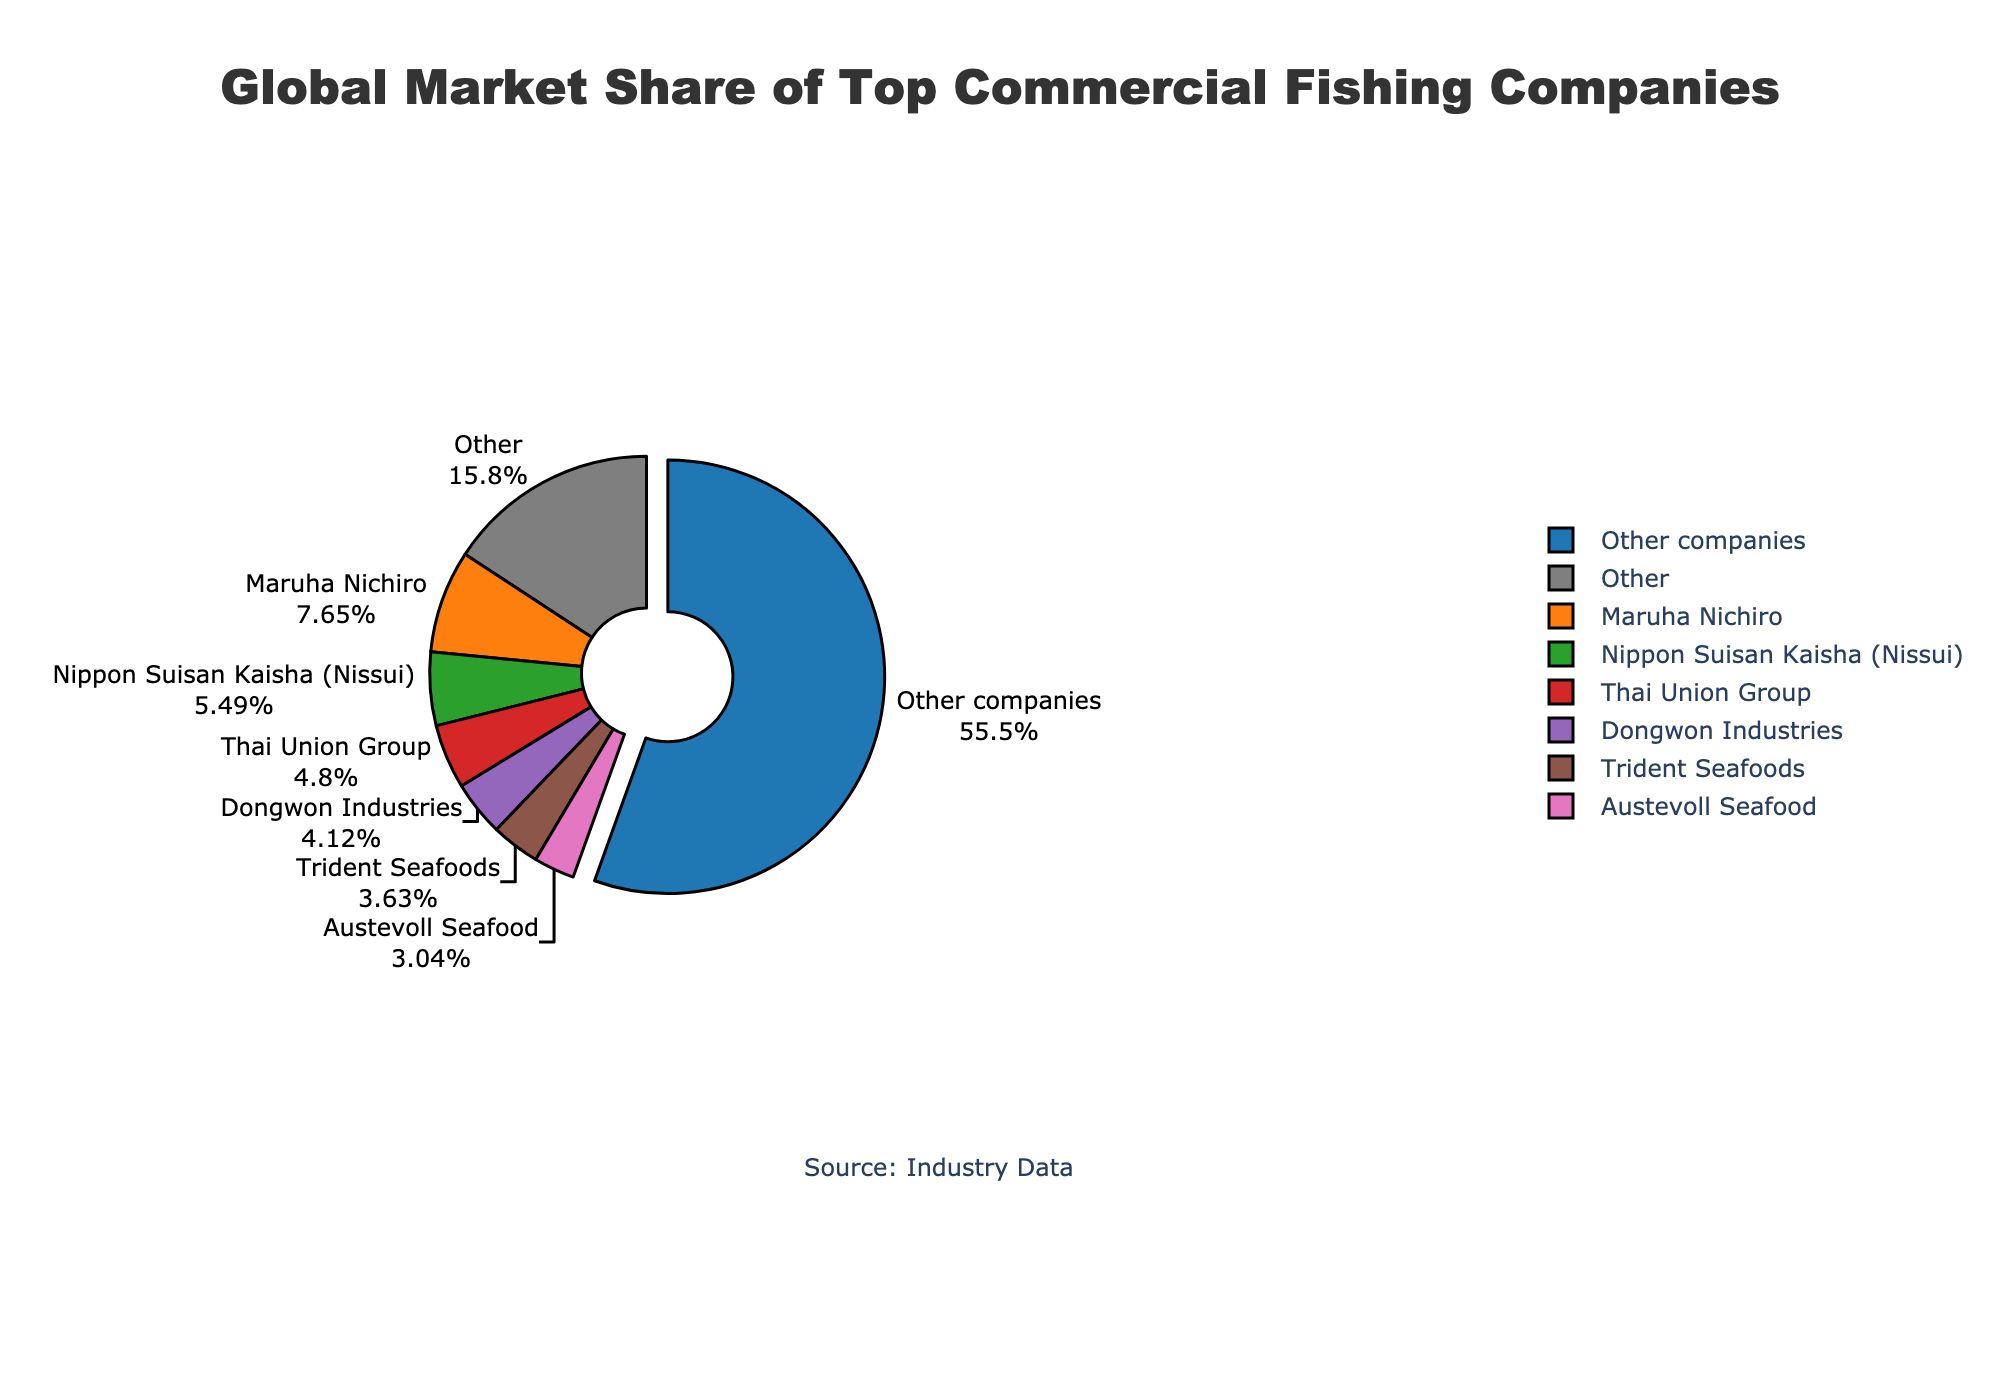Which company has the highest market share? The pie chart shows that Maruha Nichiro has a marked section with a noticeable larger slice compared to others, indicating its leading position in market share at 7.8%.
Answer: Maruha Nichiro What is the total market share of the companies grouped under "Other"? The pie chart shows a section labeled "Other" which represents various smaller companies grouped together. The market share associated with this segment is explicitly noted as 56.6%.
Answer: 56.6% How does the market share of Maruha Nichiro compare to Nippon Suisan Kaisha (Nissui)? Referring to the pie chart, Maruha Nichiro has a market share of 7.8%, while Nippon Suisan Kaisha (Nissui) has 5.6%. Subtracting these values (7.8 - 5.6), we see that Maruha Nichiro holds a 2.2% greater market share.
Answer: 2.2% Which two companies have the smallest market share among the top listed? The smallest portions in the labeled segments (excluding "Other") belong to Tri Marine International with 1.7% and Cooke Aquaculture with 1.5%.
Answer: Tri Marine International and Cooke Aquaculture Calculate the cumulative market share of the top three companies. The top three companies by market share are Maruha Nichiro (7.8%), Nippon Suisan Kaisha (Nissui) (5.6%), and Thai Union Group (4.9%). Summing these up (7.8 + 5.6 + 4.9) gives a cumulative market share of 18.3%.
Answer: 18.3% Is there a combined market share for Dongwon Industries and Trident Seafoods greater than that of Nippon Suisan Kaisha (Nissui)? Dongwon Industries has a market share of 4.2%, and Trident Seafoods has 3.7%. Summing these (4.2 + 3.7) gives 7.9%, which is greater than Nippon Suisan Kaisha (Nissui)'s share of 5.6%.
Answer: Yes What is the difference in market share between Thai Union Group and Austevoll Seafood? Thai Union Group has a market share of 4.9% and Austevoll Seafood has 3.1%. The difference between these values (4.9 - 3.1) is 1.8%.
Answer: 1.8% Estimate what percentage of the total market share is held by companies outside the top 7 listed. The pie chart groups companies not in the top 7 listed under "Other," which is noted to hold a market share of 56.6%.
Answer: 56.6% Identify the company represented by a purple color segment on the pie chart. Examining the colors in order, the purple color corresponds to Thai Union Group, which holds a market share in the 4th slot by prominence.
Answer: Thai Union Group What is the total market share of the companies with less than 3% each? Companies with shares under 3% are Kyokuyo (2.8%), Pacific Seafood Group (2.5%), Pescanova (2.3%), Sajo Industries (2.1%), Red Chamber Group (1.9%), Tri Marine International (1.7%), and Cooke Aquaculture (1.5%). Summing these (2.8 + 2.5 + 2.3 + 2.1 + 1.9 + 1.7 + 1.5) results in 14.8%.
Answer: 14.8% 